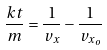<formula> <loc_0><loc_0><loc_500><loc_500>\frac { k t } { m } = \frac { 1 } { v _ { x } } - \frac { 1 } { v _ { x _ { o } } }</formula> 